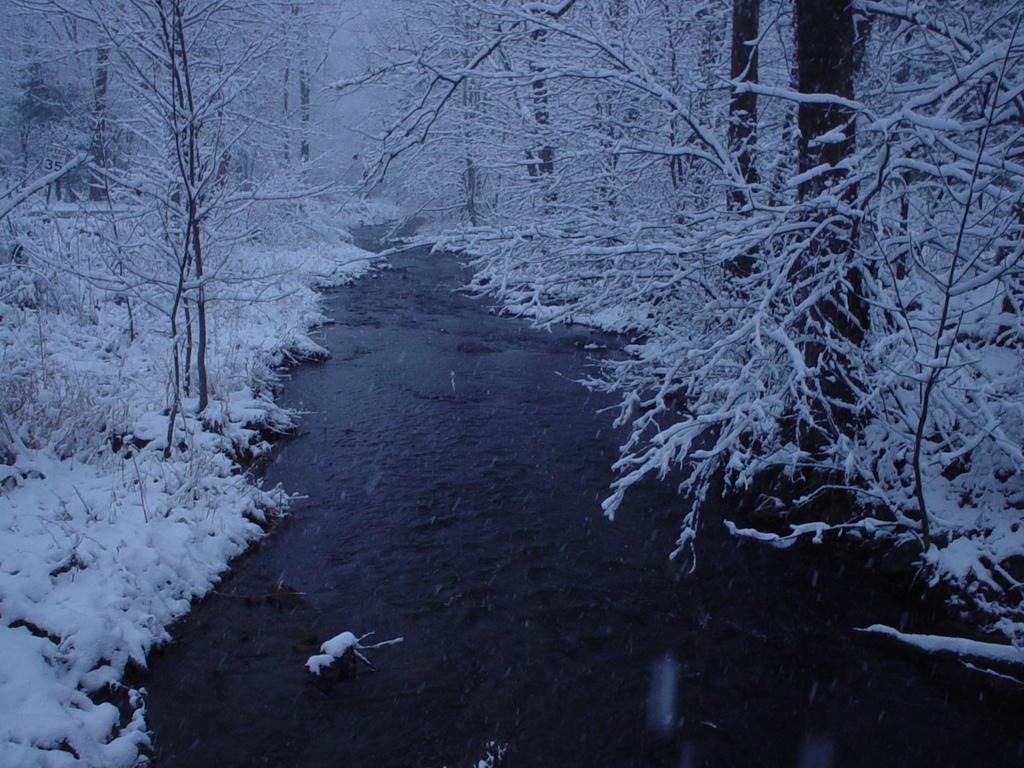What is the main feature in the foreground of the image? There is a river in the foreground of the image. What is the condition of the ground near the river? There is snow on either side of the river. Are there any other natural elements visible in the image? Yes, there are trees near the river and snow. How many pages of a book can be seen in the image? There are no pages of a book present in the image. What type of wash is being used to clean the trees in the image? There is no wash being used to clean the trees in the image; the trees are covered in snow. 